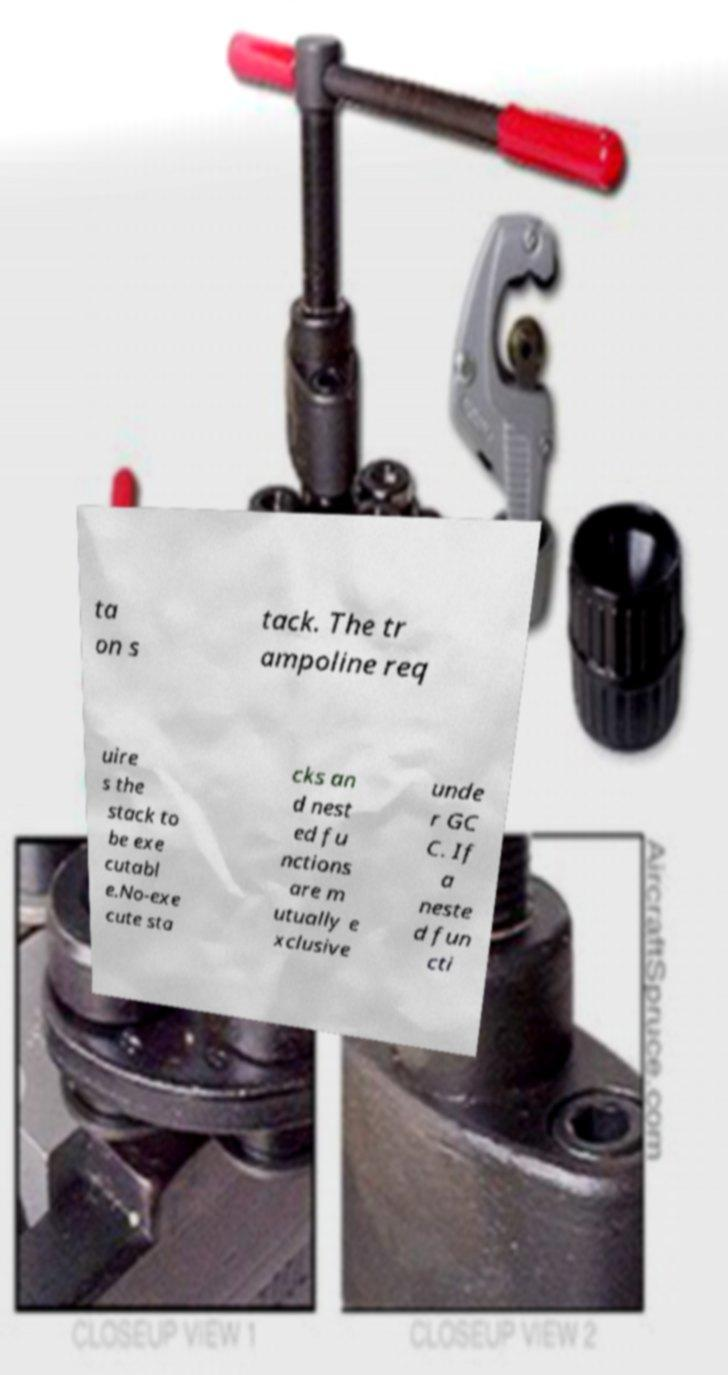Can you read and provide the text displayed in the image?This photo seems to have some interesting text. Can you extract and type it out for me? ta on s tack. The tr ampoline req uire s the stack to be exe cutabl e.No-exe cute sta cks an d nest ed fu nctions are m utually e xclusive unde r GC C. If a neste d fun cti 